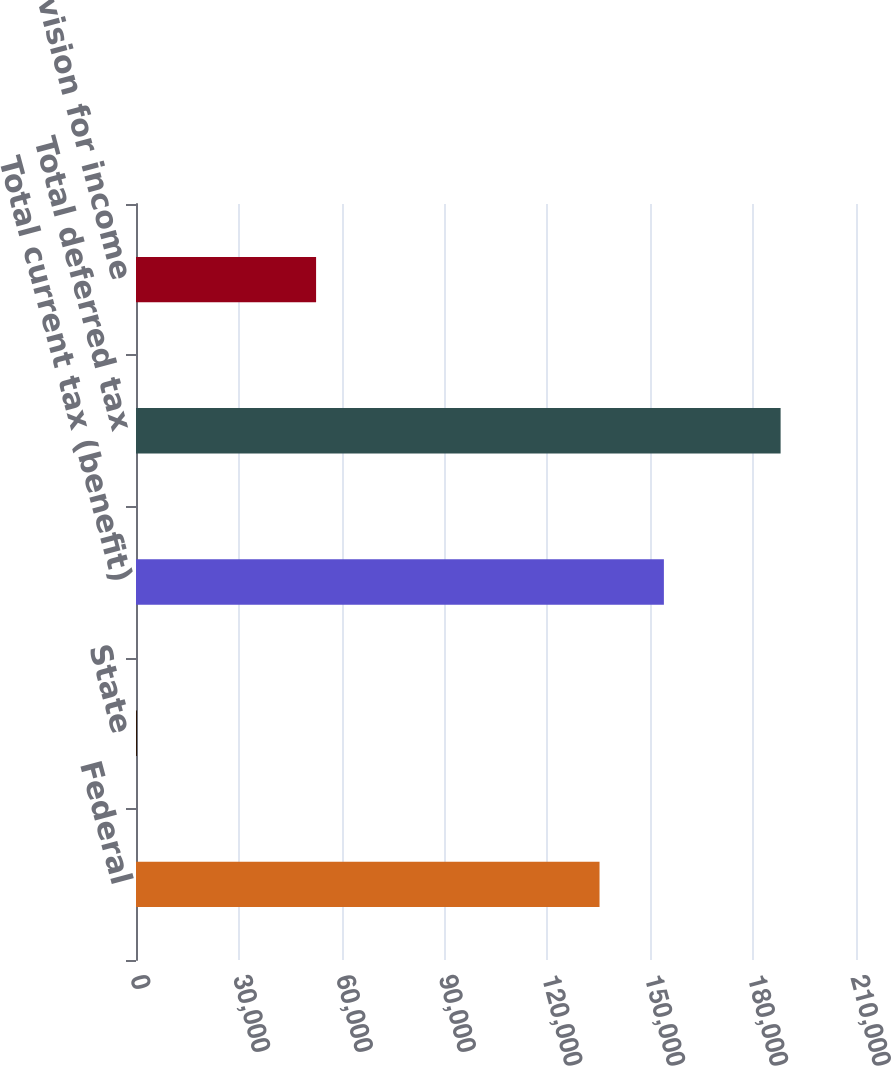Convert chart. <chart><loc_0><loc_0><loc_500><loc_500><bar_chart><fcel>Federal<fcel>State<fcel>Total current tax (benefit)<fcel>Total deferred tax<fcel>(Benefit)provision for income<nl><fcel>135196<fcel>288<fcel>153968<fcel>188010<fcel>52526<nl></chart> 